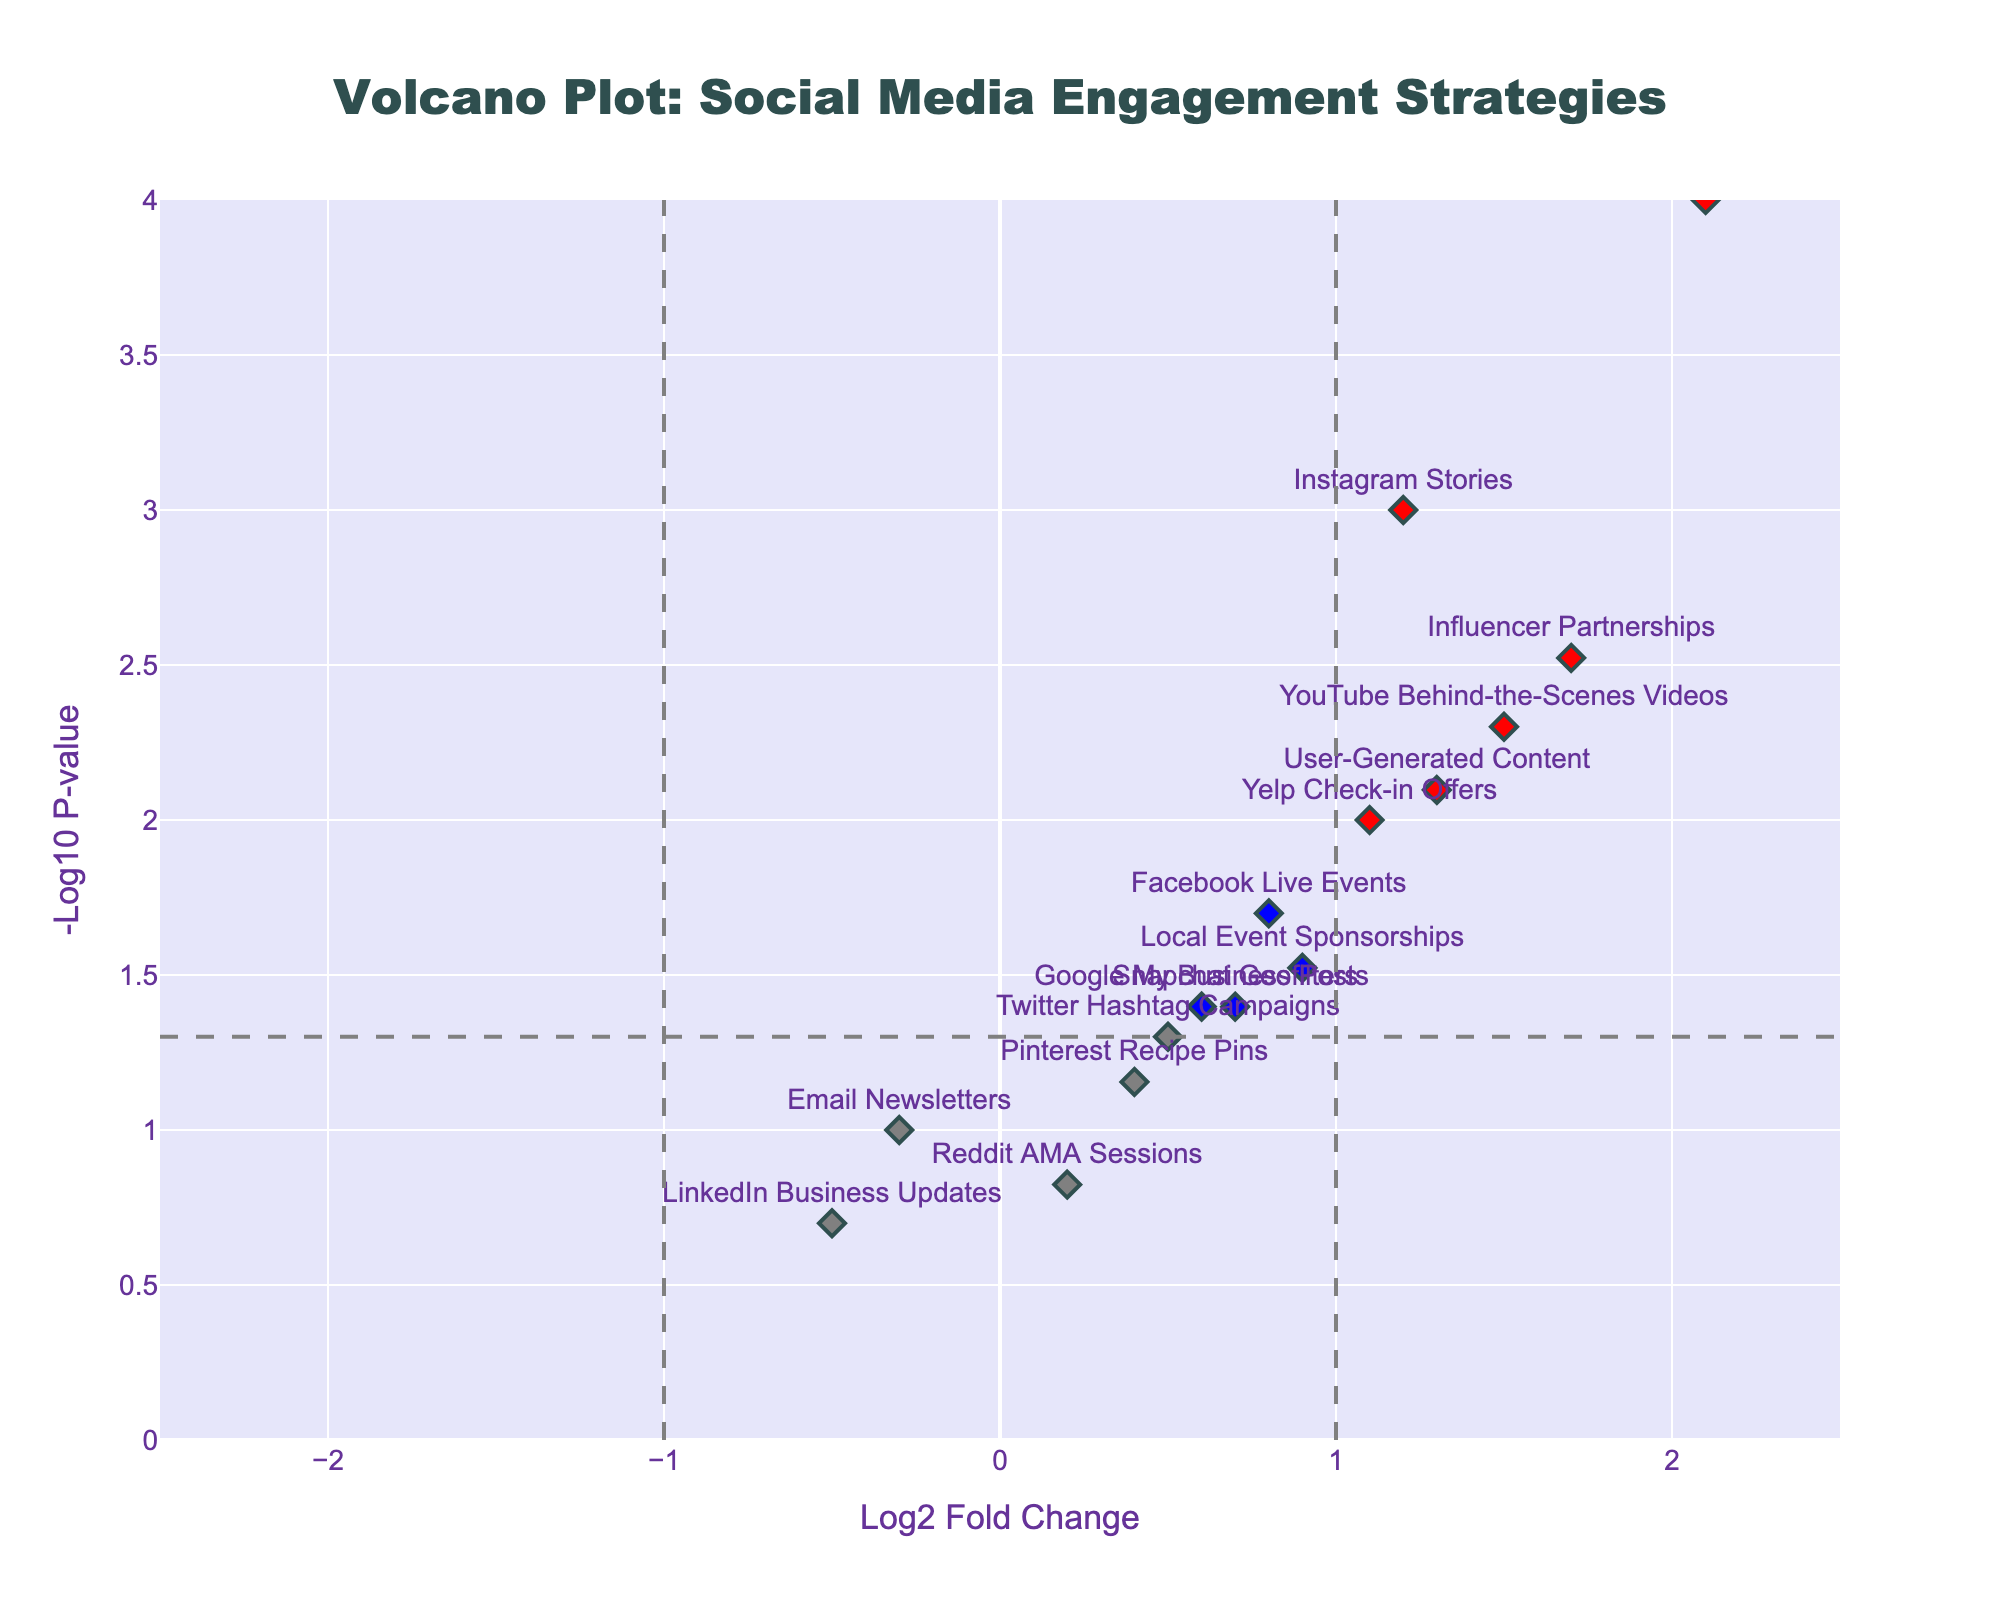How many strategies are shown with red markers? To determine this, count the number of red markers in the plot. Red markers represent strategies with log2 fold change > 1 and p-value < 0.05.
Answer: 4 What is the threshold for p-value as indicated in the plot? Look at the horizontal dashed line in the plot. This line represents the p-value threshold, which corresponds to -Log10 of 0.05, approximately 1.3.
Answer: 0.05 Which strategy has the highest engagement rate based on Log2 Fold Change? Identify the highest positive value on the x-axis (Log2 Fold Change) among the points. Look at the corresponding label.
Answer: TikTok Challenges What is the Log2 Fold Change for YouTube Behind-the-Scenes Videos? Find the data point labeled as "YouTube Behind-the-Scenes Videos" and refer to its x-axis value.
Answer: 1.5 Comparing Instagram Stories and Email Newsletters, which one has a higher significance level? Find these two strategies in the plot. Compare their y-axis values (-Log10 P-value). Higher y-axis value means higher significance.
Answer: Instagram Stories How many strategies have a Log2 Fold Change less than or equal to zero? Count all points on the plot that are located on or to the left of the y-axis (negative or zero x-axis values).
Answer: 3 Which strategy has the lowest p-value? Locate the highest point on the y-axis (-Log10 P-value) and look at the corresponding label.
Answer: TikTok Challenges Is there any strategy with a negative Log2 Fold Change and also considered statistically significant? Look on the left side of the x-axis (negative values) and see if any point crosses the horizontal threshold line.
Answer: No 